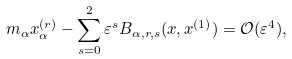Convert formula to latex. <formula><loc_0><loc_0><loc_500><loc_500>m _ { \alpha } x _ { \alpha } ^ { ( r ) } - \sum _ { s = 0 } ^ { 2 } \varepsilon ^ { s } B _ { \alpha , r , s } ( x , x ^ { ( 1 ) } ) = \mathcal { O } ( \varepsilon ^ { 4 } ) ,</formula> 